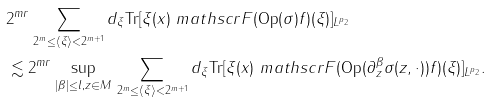<formula> <loc_0><loc_0><loc_500><loc_500>& 2 ^ { m r } \| \sum _ { 2 ^ { m } \leq \langle \xi \rangle < 2 ^ { m + 1 } } d _ { \xi } \text {Tr} [ \xi ( x ) \ m a t h s c r { F } ( \text {Op} ( \sigma ) f ) ( \xi ) ] \| _ { L ^ { p _ { 2 } } } \\ & \lesssim 2 ^ { m r } \sup _ { | \beta | \leq l , z \in M } \| \sum _ { 2 ^ { m } \leq \langle \xi \rangle < 2 ^ { m + 1 } } d _ { \xi } \text {Tr} [ \xi ( x ) \ m a t h s c r { F } ( \text {Op} ( \partial ^ { \beta } _ { z } \sigma ( z , \cdot ) ) f ) ( \xi ) ] \| _ { L ^ { p _ { 2 } } } .</formula> 